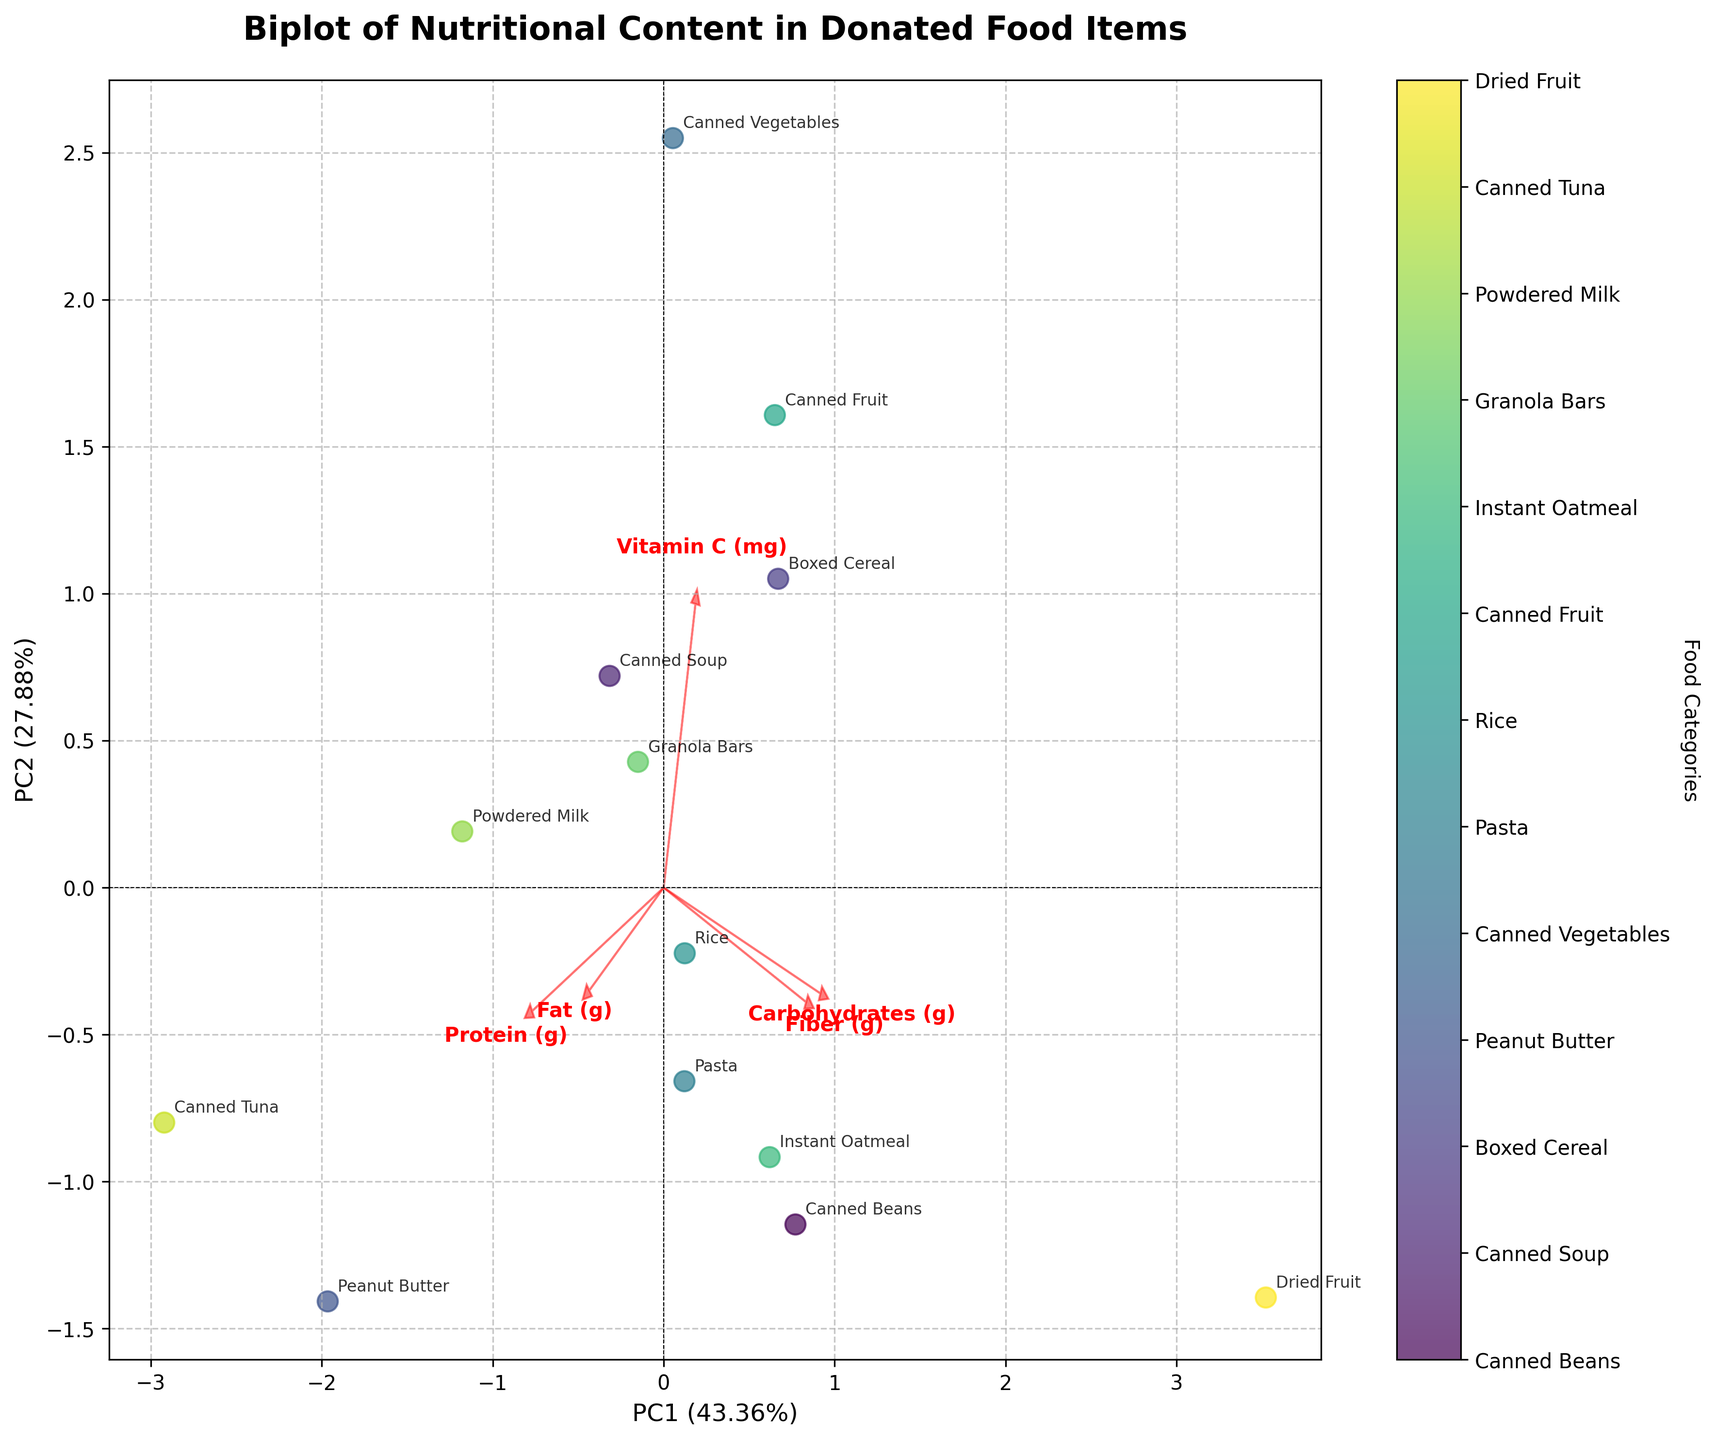What's the title of the figure? The title of the figure is displayed at the top and reads "Biplot of Nutritional Content in Donated Food Items."
Answer: Biplot of Nutritional Content in Donated Food Items How many food categories are represented in the plot? Each point in the plot represents a different food category, and there are 13 unique labels in the colorbar and annotations.
Answer: 13 Which food category has the largest PC1 score? The PC1 scores are shown along the horizontal axis. The "Dried Fruit" food category appears farthest to the right, indicating the largest PC1 score.
Answer: Dried Fruit Which nutritional content attribute has the largest loading on PC1? The feature loadings are represented by red arrows. The arrow for "Carbohydrates (g)" points farthest along the PC1 axis, indicating it has the largest loading on PC1.
Answer: Carbohydrates (g) Which nutritional content attribute has the largest loading on PC2? The feature loadings are represented by red arrows. The arrow for "Fat (g)" points farthest along the PC2 axis, indicating it has the largest loading on PC2.
Answer: Fat (g) Which two food categories are closest to each other in the plot? By visually inspecting the points in the plot, "Granola Bars" and "Canned Soup" appear closest to each other.
Answer: Granola Bars and Canned Soup How much variation is explained by PC1 and PC2 combined? The explained variance ratios are displayed on the axes labels: PC1 contributes 55.13% and PC2 contributes 23.72%. Adding these together gives the total explained variation.
Answer: 78.85% Which nutritional attribute is most associated with "Canned Vegetables"? To determine this, we observe which arrow points in the general direction of "Canned Vegetables". The arrow for "Vitamin C (mg)" points toward this category.
Answer: Vitamin C (mg) 